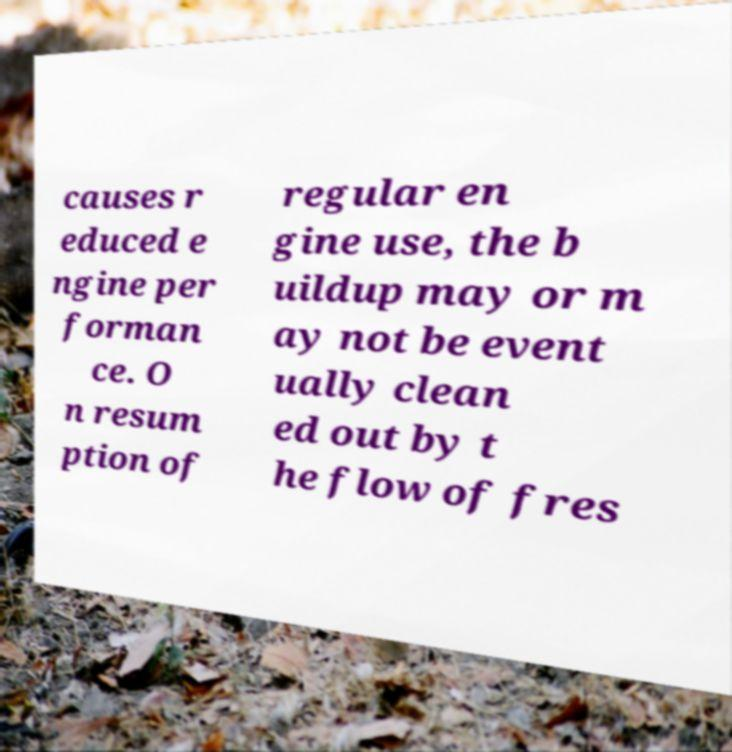Can you accurately transcribe the text from the provided image for me? causes r educed e ngine per forman ce. O n resum ption of regular en gine use, the b uildup may or m ay not be event ually clean ed out by t he flow of fres 